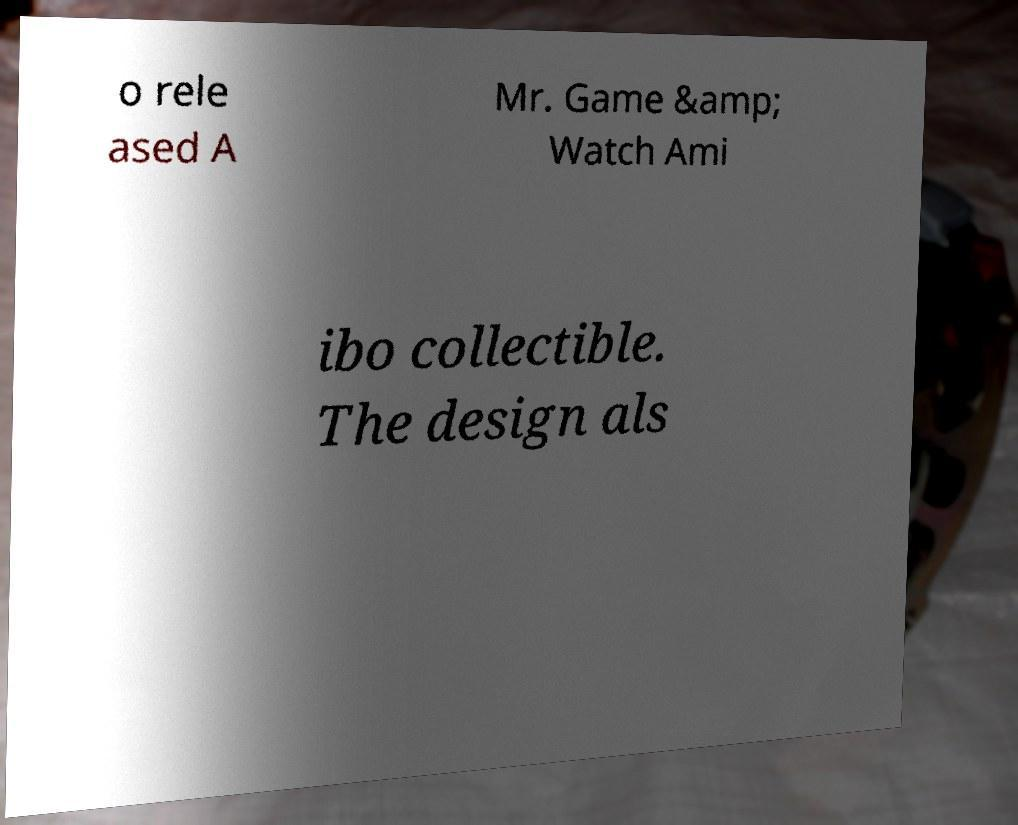There's text embedded in this image that I need extracted. Can you transcribe it verbatim? o rele ased A Mr. Game &amp; Watch Ami ibo collectible. The design als 